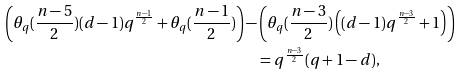<formula> <loc_0><loc_0><loc_500><loc_500>\left ( \theta _ { q } ( \frac { n - 5 } { 2 } ) ( d - 1 ) q ^ { \frac { n - 1 } { 2 } } + \theta _ { q } ( \frac { n - 1 } { 2 } ) \right ) - & \left ( \theta _ { q } ( \frac { n - 3 } { 2 } ) \left ( ( d - 1 ) q ^ { \frac { n - 3 } { 2 } } + 1 \right ) \right ) \\ & = q ^ { \frac { n - 3 } { 2 } } ( q + 1 - d ) ,</formula> 